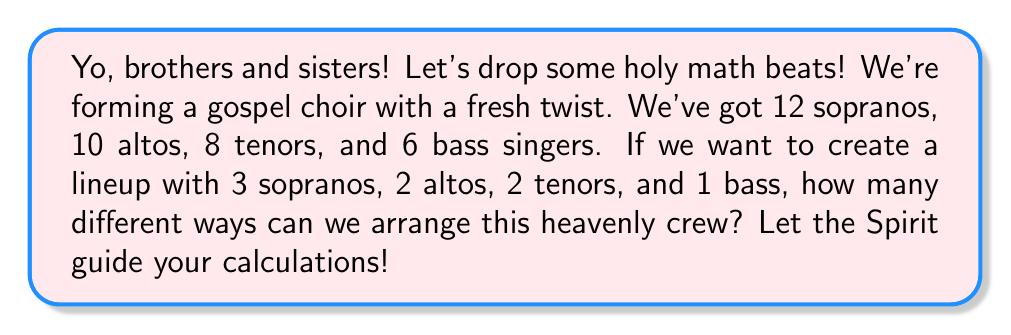Show me your answer to this math problem. Alright, let's break this down step by step:

1) We're selecting singers from each voice type:
   - 3 sopranos from 12
   - 2 altos from 10
   - 2 tenors from 8
   - 1 bass from 6

2) For each voice type, we're using the combination formula:
   $C(n,r) = \frac{n!}{r!(n-r)!}$

3) Let's calculate each combination:

   Sopranos: $C(12,3) = \frac{12!}{3!(12-3)!} = \frac{12!}{3!9!} = 220$

   Altos: $C(10,2) = \frac{10!}{2!(10-2)!} = \frac{10!}{2!8!} = 45$

   Tenors: $C(8,2) = \frac{8!}{2!(8-2)!} = \frac{8!}{2!6!} = 28$

   Bass: $C(6,1) = \frac{6!}{1!(6-1)!} = \frac{6!}{1!5!} = 6$

4) Now, according to the multiplication principle, the total number of ways to select the choir is the product of these individual combinations:

   $220 \times 45 \times 28 \times 6$

5) Let's calculate this final product:

   $220 \times 45 \times 28 \times 6 = 1,663,200$

Thus, there are 1,663,200 different ways to arrange this gospel choir lineup.
Answer: 1,663,200 